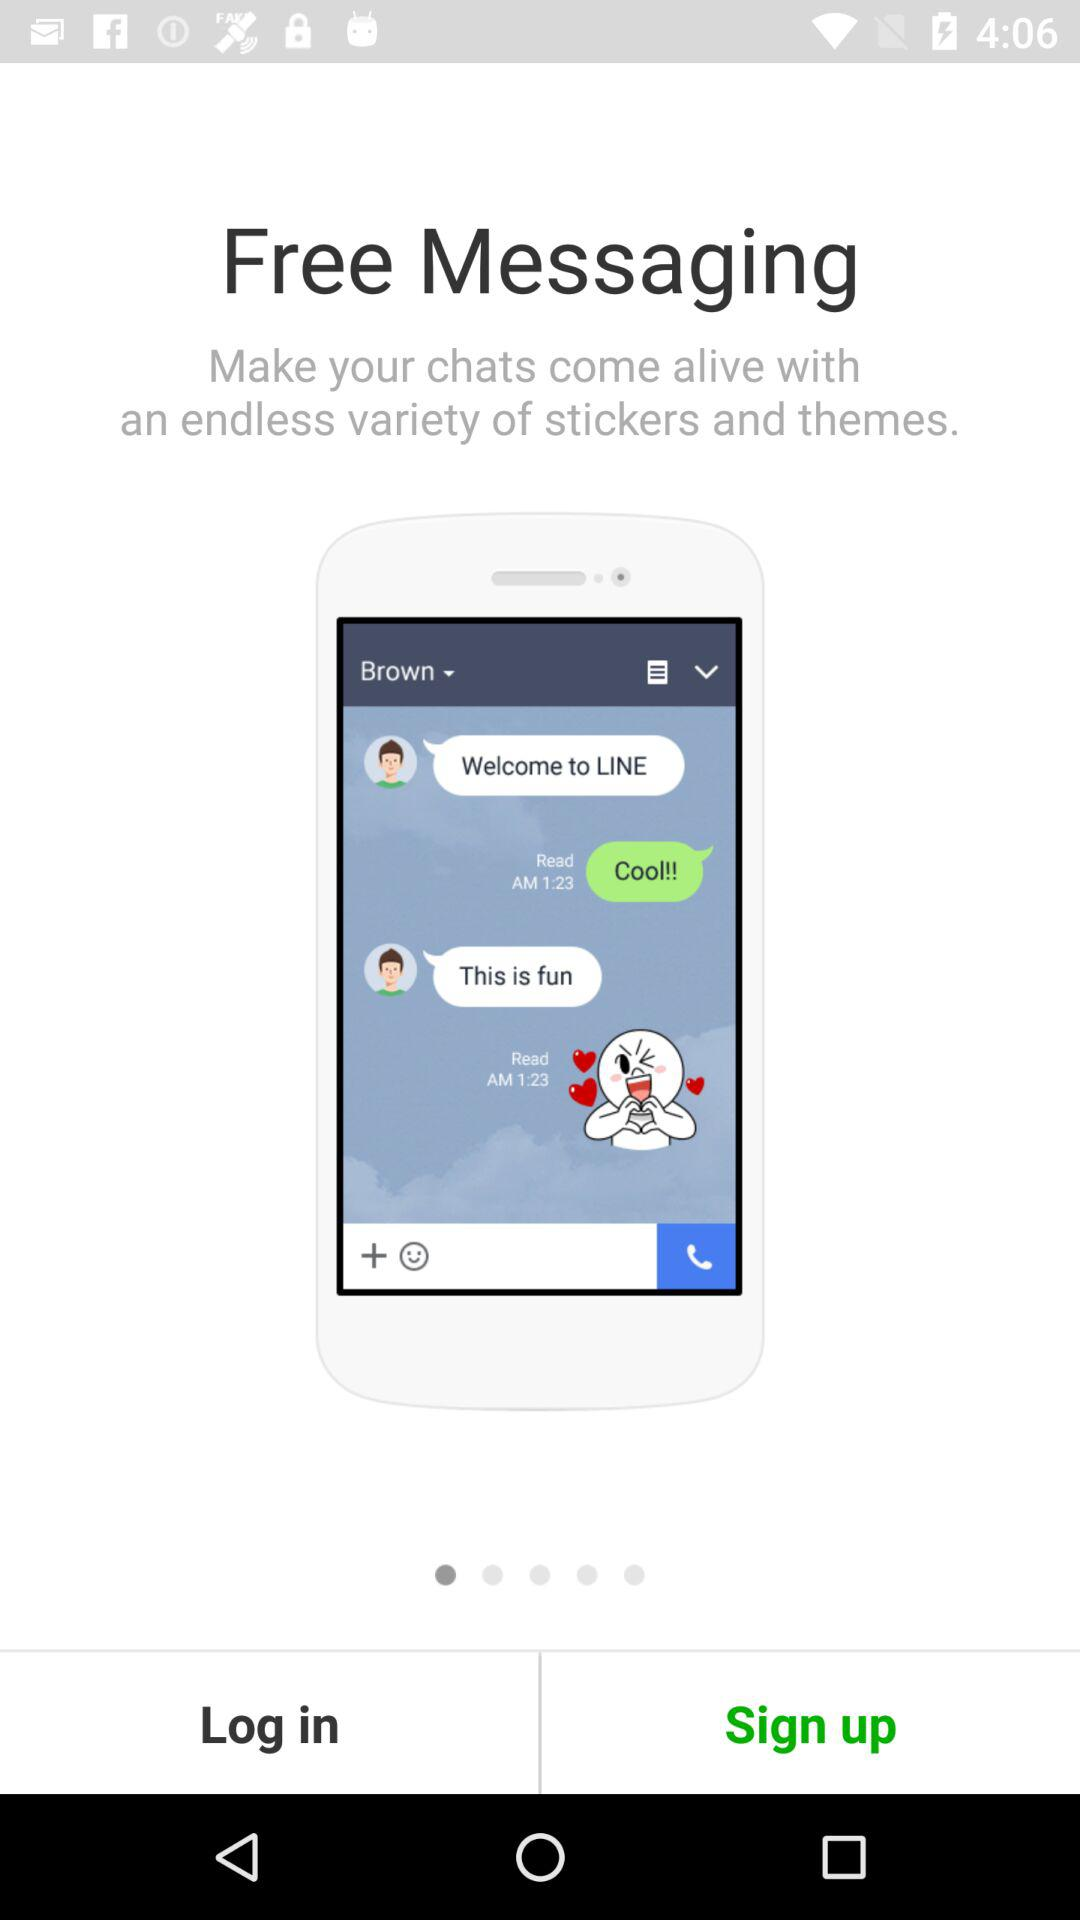What is the application name? The application name is "LINE". 